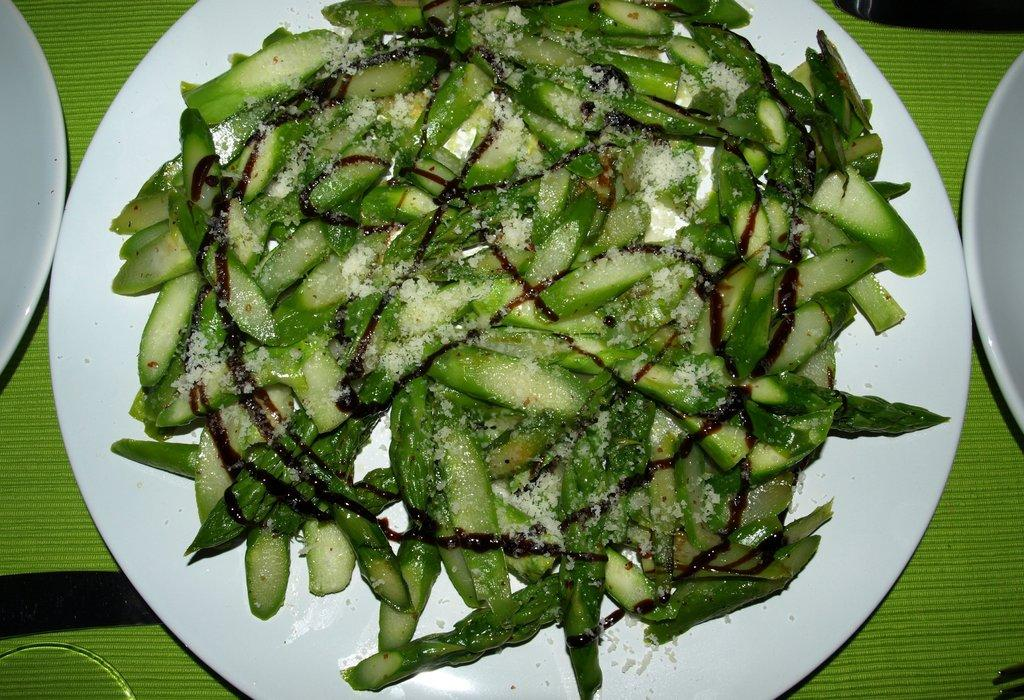What is on the plate that is visible in the image? There is food in a plate in the image. Where is the plate located in the image? The plate is placed on a table. What type of scarecrow is standing next to the table in the image? There is no scarecrow present in the image. How many times has the pot been folded in the image? There is no pot present in the image, so it cannot be folded. 